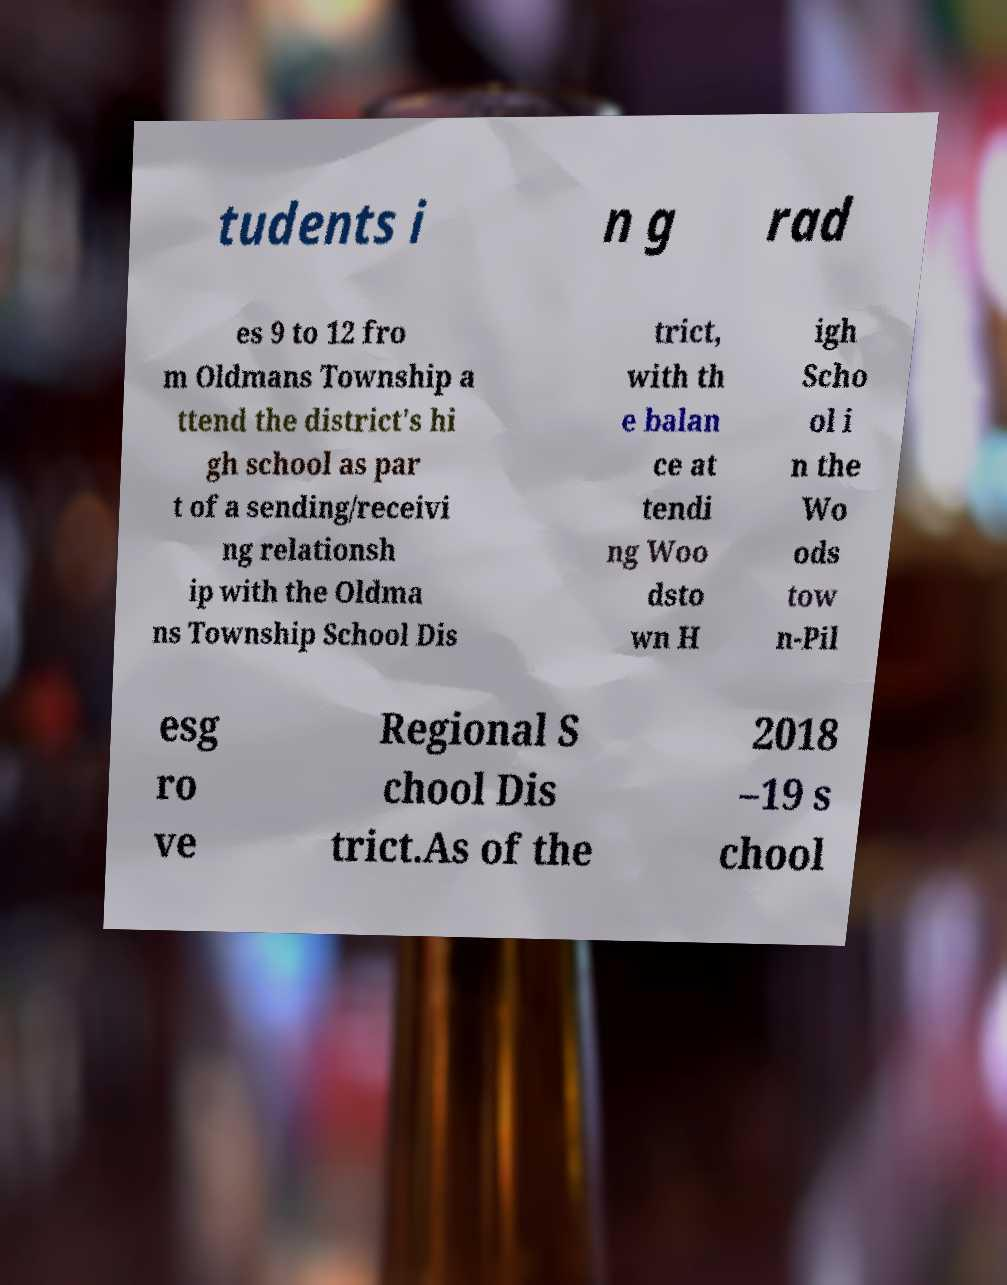Could you assist in decoding the text presented in this image and type it out clearly? tudents i n g rad es 9 to 12 fro m Oldmans Township a ttend the district's hi gh school as par t of a sending/receivi ng relationsh ip with the Oldma ns Township School Dis trict, with th e balan ce at tendi ng Woo dsto wn H igh Scho ol i n the Wo ods tow n-Pil esg ro ve Regional S chool Dis trict.As of the 2018 –19 s chool 